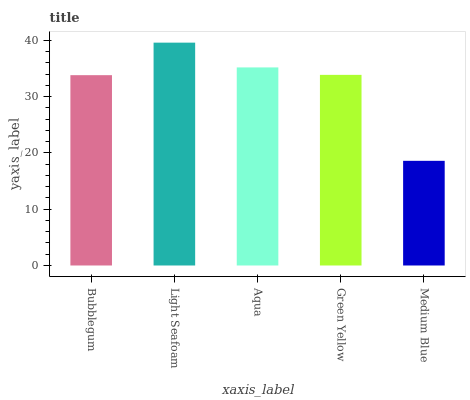Is Medium Blue the minimum?
Answer yes or no. Yes. Is Light Seafoam the maximum?
Answer yes or no. Yes. Is Aqua the minimum?
Answer yes or no. No. Is Aqua the maximum?
Answer yes or no. No. Is Light Seafoam greater than Aqua?
Answer yes or no. Yes. Is Aqua less than Light Seafoam?
Answer yes or no. Yes. Is Aqua greater than Light Seafoam?
Answer yes or no. No. Is Light Seafoam less than Aqua?
Answer yes or no. No. Is Green Yellow the high median?
Answer yes or no. Yes. Is Green Yellow the low median?
Answer yes or no. Yes. Is Aqua the high median?
Answer yes or no. No. Is Aqua the low median?
Answer yes or no. No. 